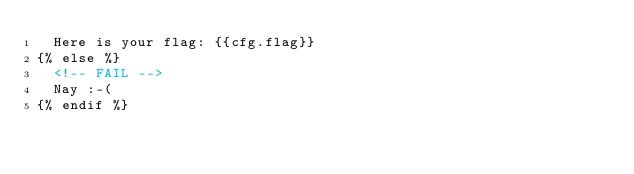Convert code to text. <code><loc_0><loc_0><loc_500><loc_500><_HTML_>  Here is your flag: {{cfg.flag}}
{% else %}
  <!-- FAIL -->
  Nay :-(
{% endif %}
</code> 